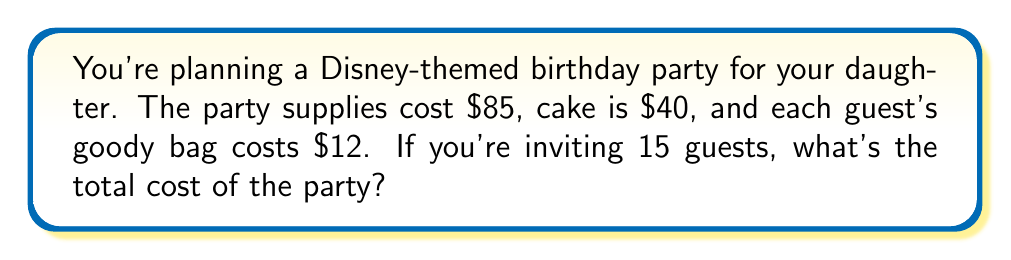Can you solve this math problem? Let's break this down step-by-step:

1. Party supplies cost: $85
2. Cake cost: $40
3. Cost per goody bag: $12
4. Number of guests: 15

To calculate the total cost, we need to:
a) Calculate the total cost of goody bags
b) Add the costs of supplies, cake, and goody bags

Step 1: Calculate the total cost of goody bags
$$ \text{Total goody bag cost} = \text{Cost per bag} \times \text{Number of guests} $$
$$ \text{Total goody bag cost} = $12 \times 15 = $180 $$

Step 2: Add all costs together
$$ \text{Total cost} = \text{Supplies} + \text{Cake} + \text{Total goody bag cost} $$
$$ \text{Total cost} = $85 + $40 + $180 = $305 $$

Therefore, the total cost of the Disney-themed birthday party is $305.
Answer: $305 